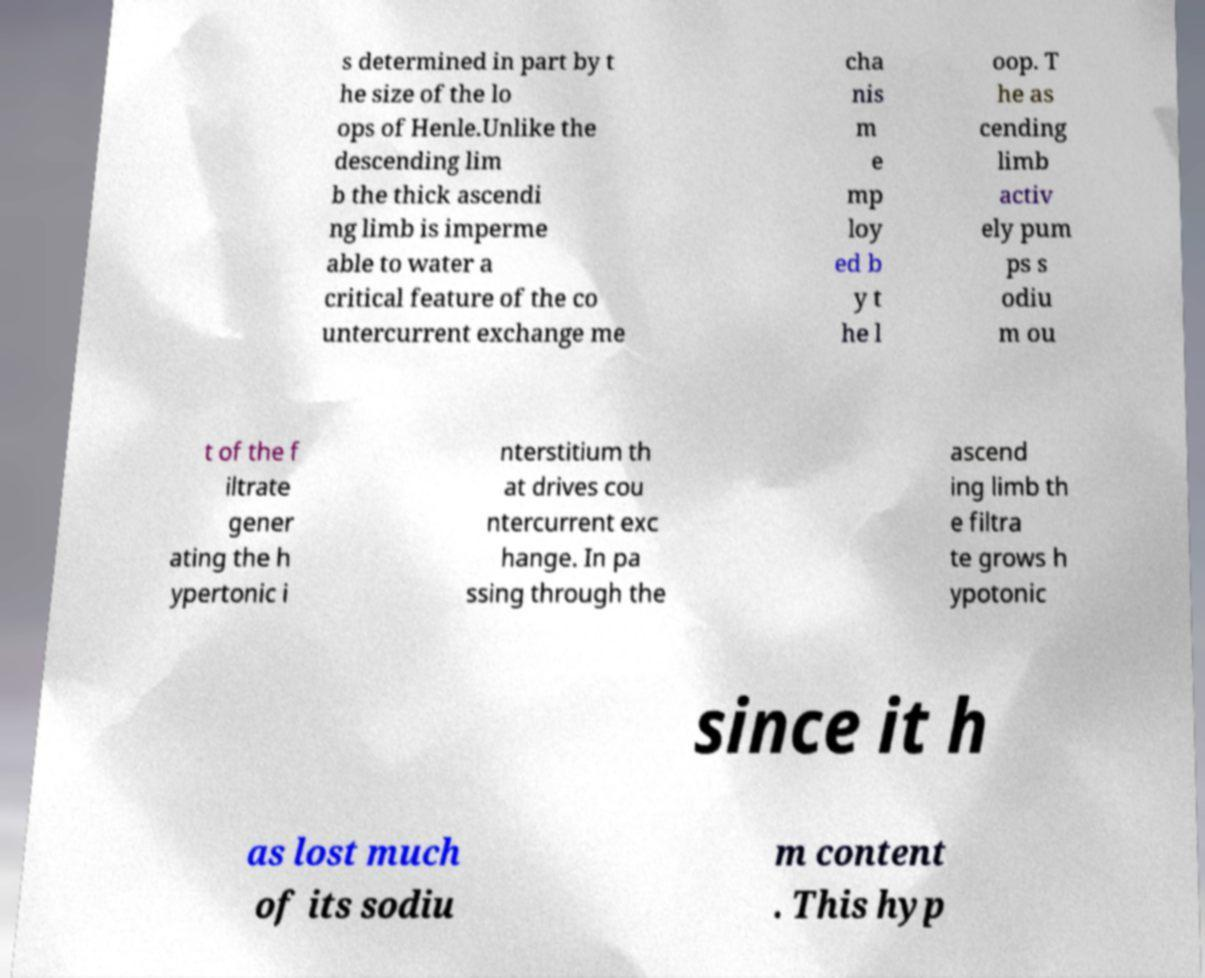What messages or text are displayed in this image? I need them in a readable, typed format. s determined in part by t he size of the lo ops of Henle.Unlike the descending lim b the thick ascendi ng limb is imperme able to water a critical feature of the co untercurrent exchange me cha nis m e mp loy ed b y t he l oop. T he as cending limb activ ely pum ps s odiu m ou t of the f iltrate gener ating the h ypertonic i nterstitium th at drives cou ntercurrent exc hange. In pa ssing through the ascend ing limb th e filtra te grows h ypotonic since it h as lost much of its sodiu m content . This hyp 